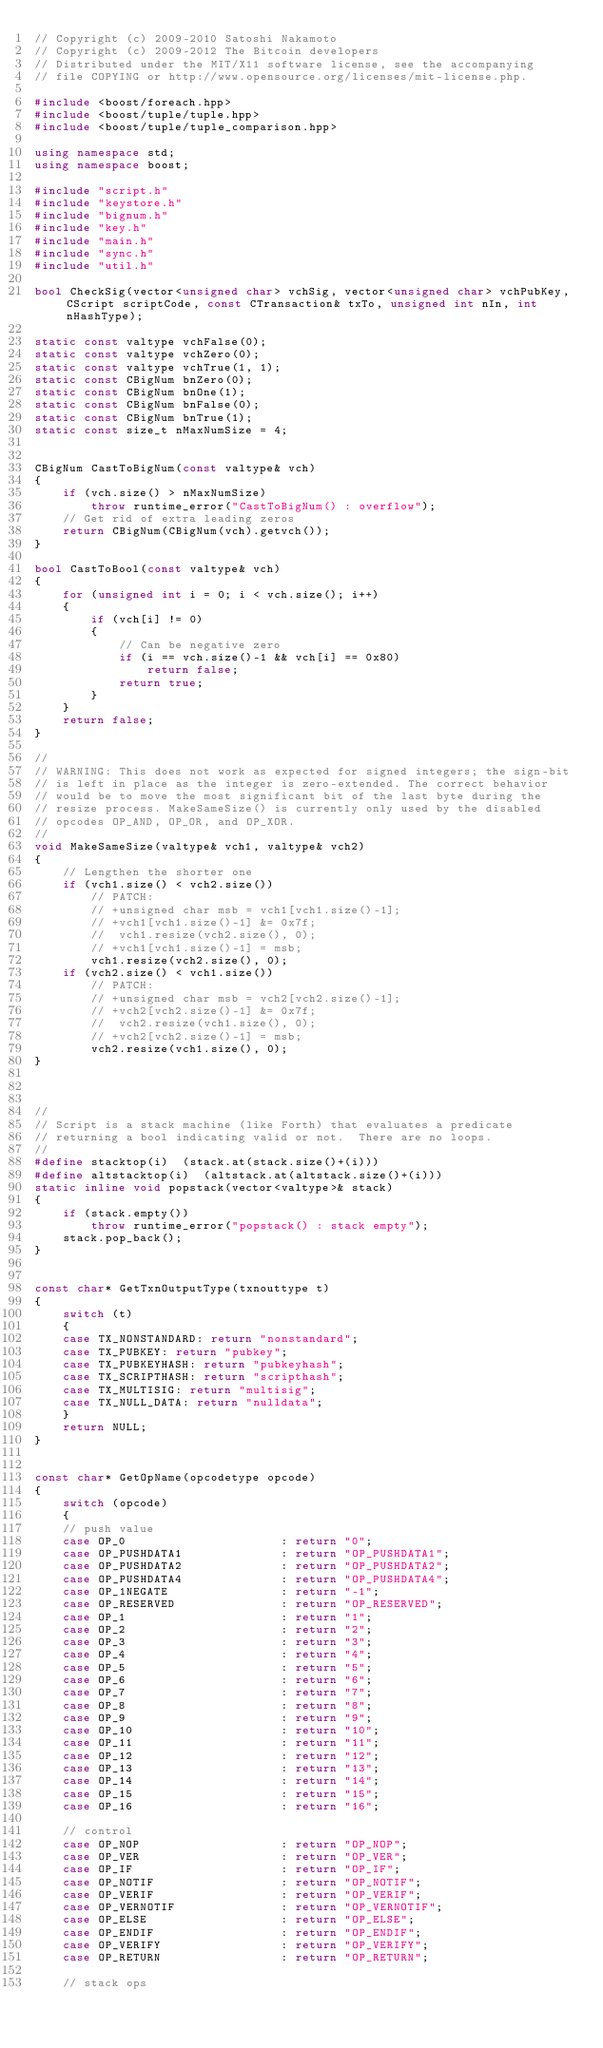<code> <loc_0><loc_0><loc_500><loc_500><_C++_>// Copyright (c) 2009-2010 Satoshi Nakamoto
// Copyright (c) 2009-2012 The Bitcoin developers
// Distributed under the MIT/X11 software license, see the accompanying
// file COPYING or http://www.opensource.org/licenses/mit-license.php.

#include <boost/foreach.hpp>
#include <boost/tuple/tuple.hpp>
#include <boost/tuple/tuple_comparison.hpp>

using namespace std;
using namespace boost;

#include "script.h"
#include "keystore.h"
#include "bignum.h"
#include "key.h"
#include "main.h"
#include "sync.h"
#include "util.h"

bool CheckSig(vector<unsigned char> vchSig, vector<unsigned char> vchPubKey, CScript scriptCode, const CTransaction& txTo, unsigned int nIn, int nHashType);

static const valtype vchFalse(0);
static const valtype vchZero(0);
static const valtype vchTrue(1, 1);
static const CBigNum bnZero(0);
static const CBigNum bnOne(1);
static const CBigNum bnFalse(0);
static const CBigNum bnTrue(1);
static const size_t nMaxNumSize = 4;


CBigNum CastToBigNum(const valtype& vch)
{
    if (vch.size() > nMaxNumSize)
        throw runtime_error("CastToBigNum() : overflow");
    // Get rid of extra leading zeros
    return CBigNum(CBigNum(vch).getvch());
}

bool CastToBool(const valtype& vch)
{
    for (unsigned int i = 0; i < vch.size(); i++)
    {
        if (vch[i] != 0)
        {
            // Can be negative zero
            if (i == vch.size()-1 && vch[i] == 0x80)
                return false;
            return true;
        }
    }
    return false;
}

//
// WARNING: This does not work as expected for signed integers; the sign-bit
// is left in place as the integer is zero-extended. The correct behavior
// would be to move the most significant bit of the last byte during the
// resize process. MakeSameSize() is currently only used by the disabled
// opcodes OP_AND, OP_OR, and OP_XOR.
//
void MakeSameSize(valtype& vch1, valtype& vch2)
{
    // Lengthen the shorter one
    if (vch1.size() < vch2.size())
        // PATCH:
        // +unsigned char msb = vch1[vch1.size()-1];
        // +vch1[vch1.size()-1] &= 0x7f;
        //  vch1.resize(vch2.size(), 0);
        // +vch1[vch1.size()-1] = msb;
        vch1.resize(vch2.size(), 0);
    if (vch2.size() < vch1.size())
        // PATCH:
        // +unsigned char msb = vch2[vch2.size()-1];
        // +vch2[vch2.size()-1] &= 0x7f;
        //  vch2.resize(vch1.size(), 0);
        // +vch2[vch2.size()-1] = msb;
        vch2.resize(vch1.size(), 0);
}



//
// Script is a stack machine (like Forth) that evaluates a predicate
// returning a bool indicating valid or not.  There are no loops.
//
#define stacktop(i)  (stack.at(stack.size()+(i)))
#define altstacktop(i)  (altstack.at(altstack.size()+(i)))
static inline void popstack(vector<valtype>& stack)
{
    if (stack.empty())
        throw runtime_error("popstack() : stack empty");
    stack.pop_back();
}


const char* GetTxnOutputType(txnouttype t)
{
    switch (t)
    {
    case TX_NONSTANDARD: return "nonstandard";
    case TX_PUBKEY: return "pubkey";
    case TX_PUBKEYHASH: return "pubkeyhash";
    case TX_SCRIPTHASH: return "scripthash";
    case TX_MULTISIG: return "multisig";
    case TX_NULL_DATA: return "nulldata";
    }
    return NULL;
}


const char* GetOpName(opcodetype opcode)
{
    switch (opcode)
    {
    // push value
    case OP_0                      : return "0";
    case OP_PUSHDATA1              : return "OP_PUSHDATA1";
    case OP_PUSHDATA2              : return "OP_PUSHDATA2";
    case OP_PUSHDATA4              : return "OP_PUSHDATA4";
    case OP_1NEGATE                : return "-1";
    case OP_RESERVED               : return "OP_RESERVED";
    case OP_1                      : return "1";
    case OP_2                      : return "2";
    case OP_3                      : return "3";
    case OP_4                      : return "4";
    case OP_5                      : return "5";
    case OP_6                      : return "6";
    case OP_7                      : return "7";
    case OP_8                      : return "8";
    case OP_9                      : return "9";
    case OP_10                     : return "10";
    case OP_11                     : return "11";
    case OP_12                     : return "12";
    case OP_13                     : return "13";
    case OP_14                     : return "14";
    case OP_15                     : return "15";
    case OP_16                     : return "16";

    // control
    case OP_NOP                    : return "OP_NOP";
    case OP_VER                    : return "OP_VER";
    case OP_IF                     : return "OP_IF";
    case OP_NOTIF                  : return "OP_NOTIF";
    case OP_VERIF                  : return "OP_VERIF";
    case OP_VERNOTIF               : return "OP_VERNOTIF";
    case OP_ELSE                   : return "OP_ELSE";
    case OP_ENDIF                  : return "OP_ENDIF";
    case OP_VERIFY                 : return "OP_VERIFY";
    case OP_RETURN                 : return "OP_RETURN";

    // stack ops</code> 